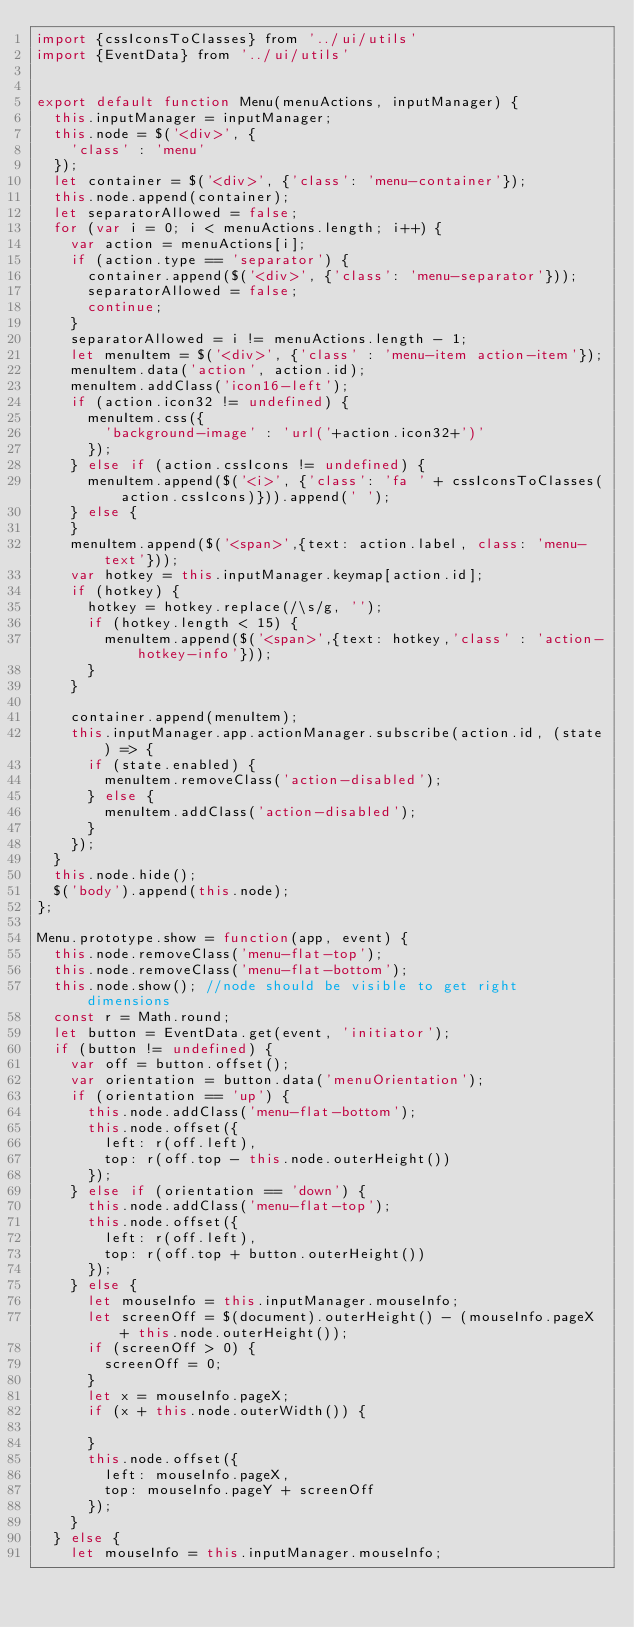Convert code to text. <code><loc_0><loc_0><loc_500><loc_500><_JavaScript_>import {cssIconsToClasses} from '../ui/utils'
import {EventData} from '../ui/utils'


export default function Menu(menuActions, inputManager) {
  this.inputManager = inputManager;
  this.node = $('<div>', {
    'class' : 'menu'
  });
  let container = $('<div>', {'class': 'menu-container'});
  this.node.append(container);
  let separatorAllowed = false;
  for (var i = 0; i < menuActions.length; i++) {
    var action = menuActions[i];
    if (action.type == 'separator') {
      container.append($('<div>', {'class': 'menu-separator'}));
      separatorAllowed = false;
      continue;
    }
    separatorAllowed = i != menuActions.length - 1;
    let menuItem = $('<div>', {'class' : 'menu-item action-item'});
    menuItem.data('action', action.id);
    menuItem.addClass('icon16-left');
    if (action.icon32 != undefined) {
      menuItem.css({
        'background-image' : 'url('+action.icon32+')'
      });
    } else if (action.cssIcons != undefined) {
      menuItem.append($('<i>', {'class': 'fa ' + cssIconsToClasses(action.cssIcons)})).append(' ');
    } else {
    }
    menuItem.append($('<span>',{text: action.label, class: 'menu-text'}));
    var hotkey = this.inputManager.keymap[action.id];
    if (hotkey) {
      hotkey = hotkey.replace(/\s/g, '');
      if (hotkey.length < 15) {
        menuItem.append($('<span>',{text: hotkey,'class' : 'action-hotkey-info'}));
      }
    }
    
    container.append(menuItem);
    this.inputManager.app.actionManager.subscribe(action.id, (state) => {
      if (state.enabled) {
        menuItem.removeClass('action-disabled');
      } else {
        menuItem.addClass('action-disabled');
      }
    });
  }
  this.node.hide();
  $('body').append(this.node);
};

Menu.prototype.show = function(app, event) {
  this.node.removeClass('menu-flat-top');
  this.node.removeClass('menu-flat-bottom');
  this.node.show(); //node should be visible to get right dimensions
  const r = Math.round;
  let button = EventData.get(event, 'initiator');
  if (button != undefined) {
    var off = button.offset();
    var orientation = button.data('menuOrientation');
    if (orientation == 'up') {
      this.node.addClass('menu-flat-bottom');
      this.node.offset({
        left: r(off.left),
        top: r(off.top - this.node.outerHeight())
      });
    } else if (orientation == 'down') {
      this.node.addClass('menu-flat-top');
      this.node.offset({
        left: r(off.left),
        top: r(off.top + button.outerHeight())
      });
    } else {
      let mouseInfo = this.inputManager.mouseInfo;
      let screenOff = $(document).outerHeight() - (mouseInfo.pageX + this.node.outerHeight());
      if (screenOff > 0) {
        screenOff = 0;
      }
      let x = mouseInfo.pageX;
      if (x + this.node.outerWidth()) {
        
      }
      this.node.offset({
        left: mouseInfo.pageX,
        top: mouseInfo.pageY + screenOff 
      });
    }
  } else {
    let mouseInfo = this.inputManager.mouseInfo;</code> 